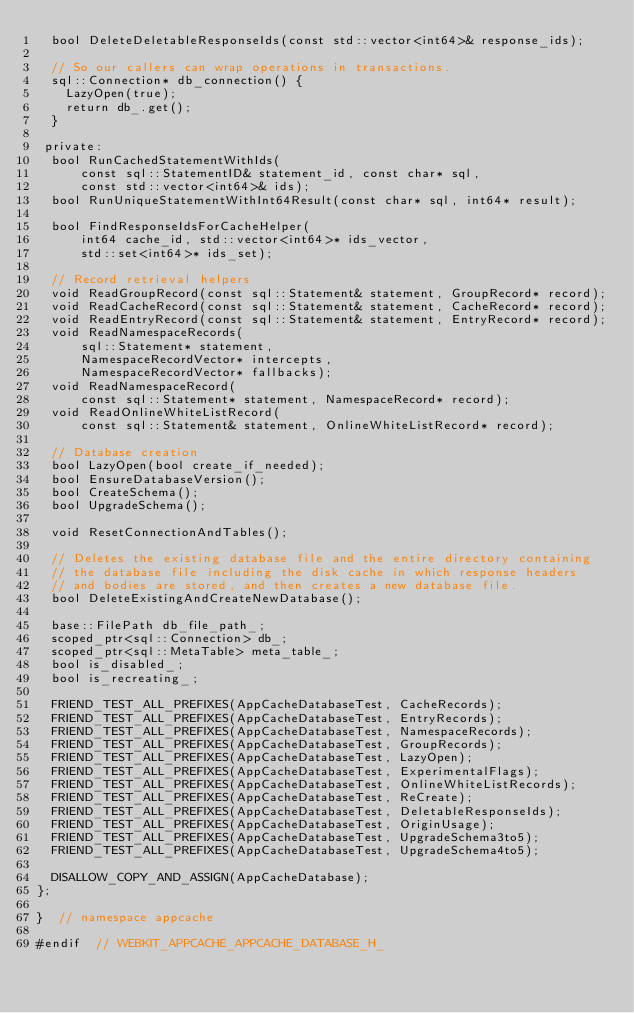Convert code to text. <code><loc_0><loc_0><loc_500><loc_500><_C_>  bool DeleteDeletableResponseIds(const std::vector<int64>& response_ids);

  // So our callers can wrap operations in transactions.
  sql::Connection* db_connection() {
    LazyOpen(true);
    return db_.get();
  }

 private:
  bool RunCachedStatementWithIds(
      const sql::StatementID& statement_id, const char* sql,
      const std::vector<int64>& ids);
  bool RunUniqueStatementWithInt64Result(const char* sql, int64* result);

  bool FindResponseIdsForCacheHelper(
      int64 cache_id, std::vector<int64>* ids_vector,
      std::set<int64>* ids_set);

  // Record retrieval helpers
  void ReadGroupRecord(const sql::Statement& statement, GroupRecord* record);
  void ReadCacheRecord(const sql::Statement& statement, CacheRecord* record);
  void ReadEntryRecord(const sql::Statement& statement, EntryRecord* record);
  void ReadNamespaceRecords(
      sql::Statement* statement,
      NamespaceRecordVector* intercepts,
      NamespaceRecordVector* fallbacks);
  void ReadNamespaceRecord(
      const sql::Statement* statement, NamespaceRecord* record);
  void ReadOnlineWhiteListRecord(
      const sql::Statement& statement, OnlineWhiteListRecord* record);

  // Database creation
  bool LazyOpen(bool create_if_needed);
  bool EnsureDatabaseVersion();
  bool CreateSchema();
  bool UpgradeSchema();

  void ResetConnectionAndTables();

  // Deletes the existing database file and the entire directory containing
  // the database file including the disk cache in which response headers
  // and bodies are stored, and then creates a new database file.
  bool DeleteExistingAndCreateNewDatabase();

  base::FilePath db_file_path_;
  scoped_ptr<sql::Connection> db_;
  scoped_ptr<sql::MetaTable> meta_table_;
  bool is_disabled_;
  bool is_recreating_;

  FRIEND_TEST_ALL_PREFIXES(AppCacheDatabaseTest, CacheRecords);
  FRIEND_TEST_ALL_PREFIXES(AppCacheDatabaseTest, EntryRecords);
  FRIEND_TEST_ALL_PREFIXES(AppCacheDatabaseTest, NamespaceRecords);
  FRIEND_TEST_ALL_PREFIXES(AppCacheDatabaseTest, GroupRecords);
  FRIEND_TEST_ALL_PREFIXES(AppCacheDatabaseTest, LazyOpen);
  FRIEND_TEST_ALL_PREFIXES(AppCacheDatabaseTest, ExperimentalFlags);
  FRIEND_TEST_ALL_PREFIXES(AppCacheDatabaseTest, OnlineWhiteListRecords);
  FRIEND_TEST_ALL_PREFIXES(AppCacheDatabaseTest, ReCreate);
  FRIEND_TEST_ALL_PREFIXES(AppCacheDatabaseTest, DeletableResponseIds);
  FRIEND_TEST_ALL_PREFIXES(AppCacheDatabaseTest, OriginUsage);
  FRIEND_TEST_ALL_PREFIXES(AppCacheDatabaseTest, UpgradeSchema3to5);
  FRIEND_TEST_ALL_PREFIXES(AppCacheDatabaseTest, UpgradeSchema4to5);

  DISALLOW_COPY_AND_ASSIGN(AppCacheDatabase);
};

}  // namespace appcache

#endif  // WEBKIT_APPCACHE_APPCACHE_DATABASE_H_
</code> 